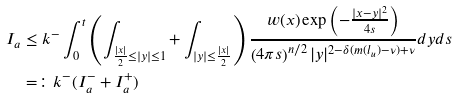Convert formula to latex. <formula><loc_0><loc_0><loc_500><loc_500>I _ { a } & \leq k ^ { - } \int _ { 0 } ^ { t } \left ( \int _ { \frac { | x | } { 2 } \leq | y | \leq 1 } + \int _ { | y | \leq \frac { | x | } { 2 } } \right ) \frac { w ( x ) \exp \left ( - \frac { | x - y | ^ { 2 } } { 4 s } \right ) } { \left ( 4 \pi s \right ) ^ { n / 2 } | y | ^ { 2 - \delta ( m ( l _ { u } ) - \nu ) + \nu } } d y d s \\ & = \colon k ^ { - } ( I _ { a } ^ { - } + I _ { a } ^ { + } )</formula> 